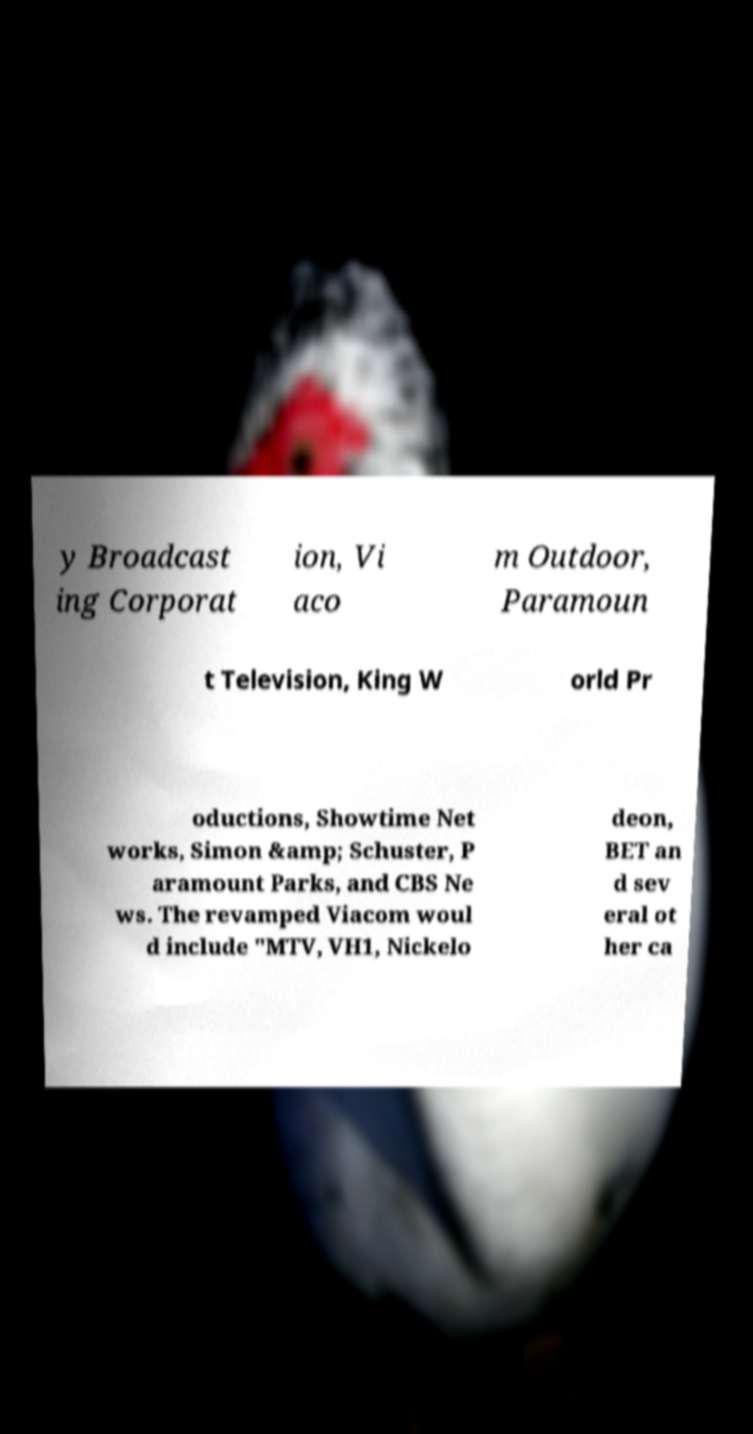Can you accurately transcribe the text from the provided image for me? y Broadcast ing Corporat ion, Vi aco m Outdoor, Paramoun t Television, King W orld Pr oductions, Showtime Net works, Simon &amp; Schuster, P aramount Parks, and CBS Ne ws. The revamped Viacom woul d include "MTV, VH1, Nickelo deon, BET an d sev eral ot her ca 